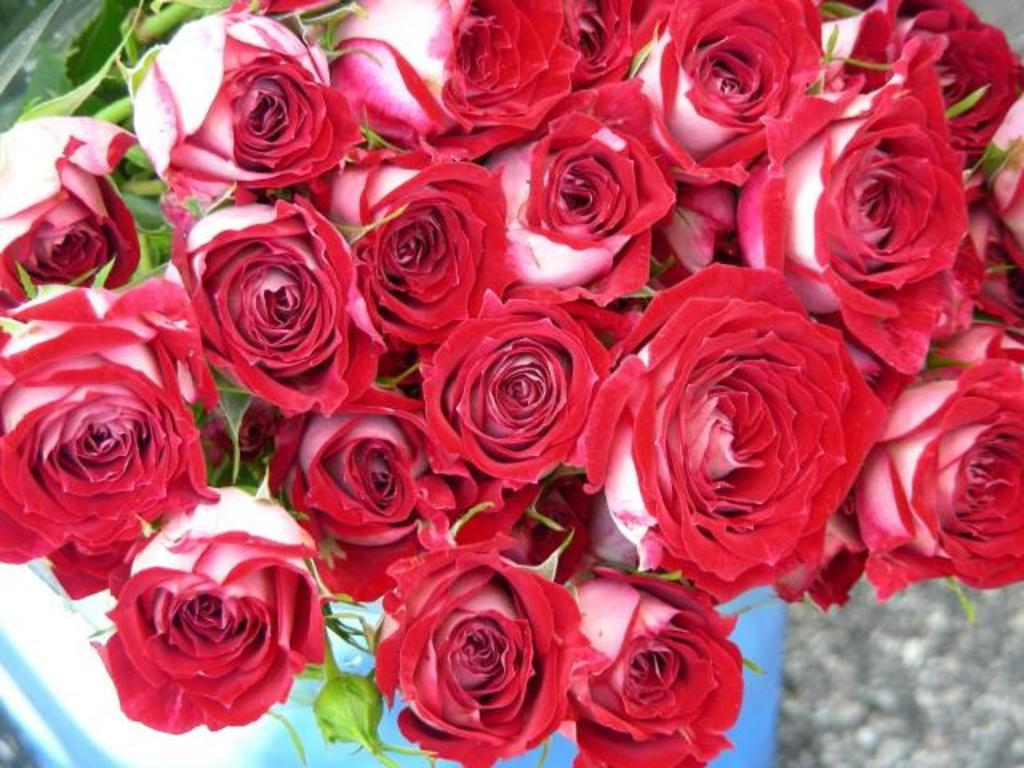What type of flowers are in the image? There are red color rose flowers in the image. Where are the leaves located in the image? The leaves are at the left top of the image. What type of bone can be seen in the image? There is no bone present in the image; it features red color rose flowers and leaves. What fact can be learned about the ring in the image? There is no ring present in the image, so no fact can be learned about it. 